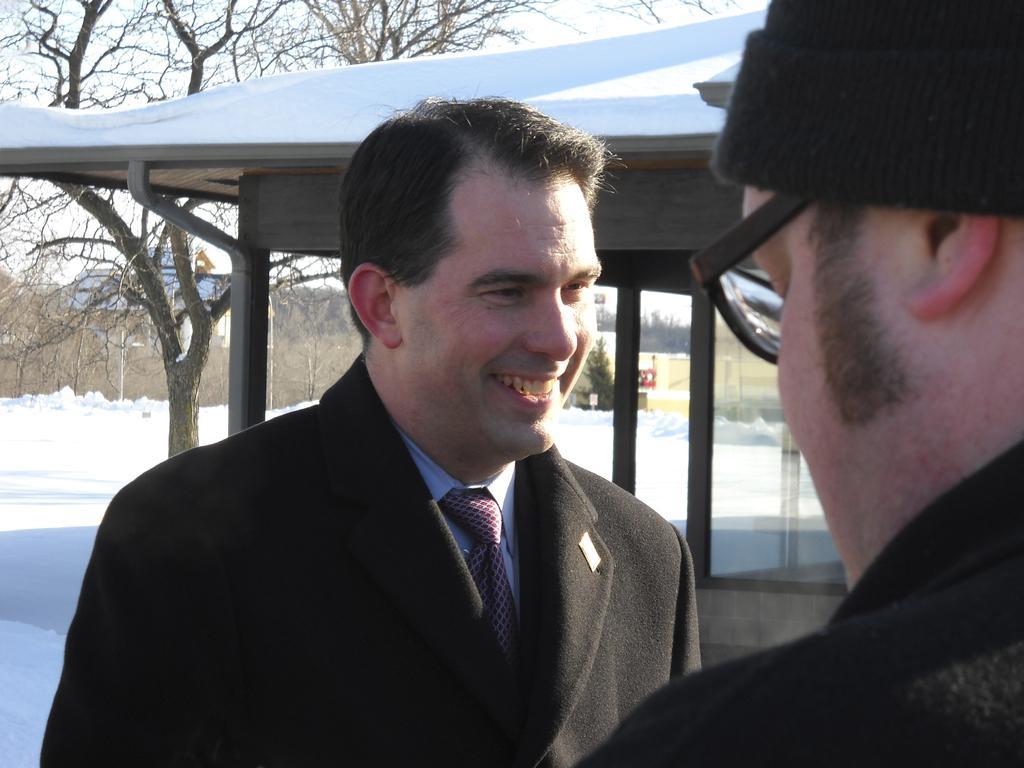Please provide a concise description of this image. In this image we can see two persons. One person wearing spectacles and cap. One person is wearing a coat with tie. In the background, we can see a building, tree and sky. 